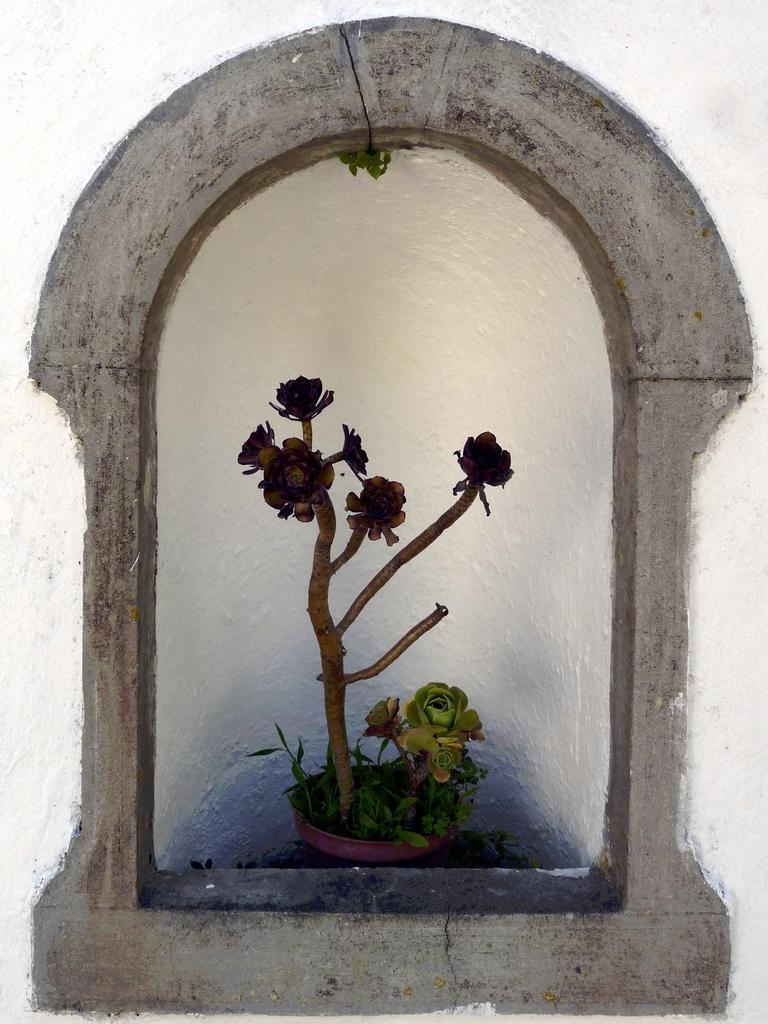Please provide a concise description of this image. The picture is a painting of a cornerstone. In the center of the picture there is a flower pot. In the pot there are plants. In the center of the picture there are flowers. 